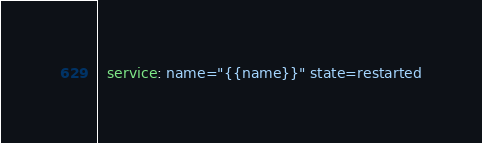Convert code to text. <code><loc_0><loc_0><loc_500><loc_500><_YAML_>  service: name="{{name}}" state=restarted
</code> 